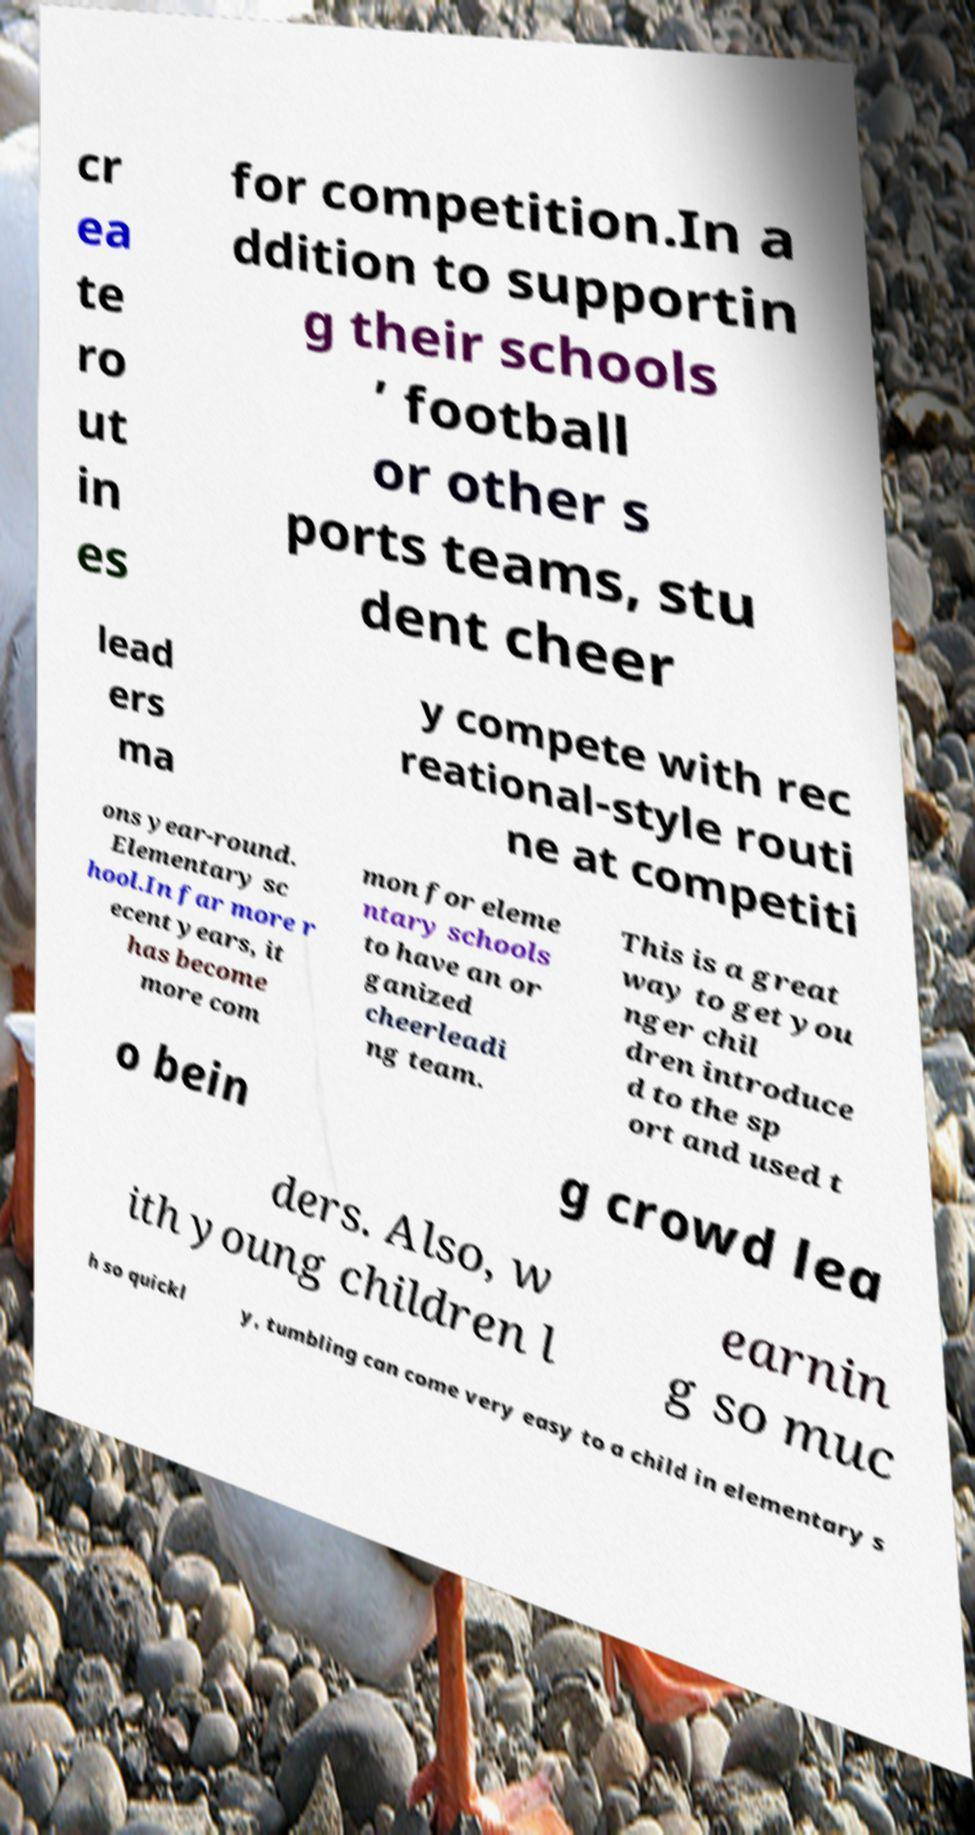Could you extract and type out the text from this image? cr ea te ro ut in es for competition.In a ddition to supportin g their schools ’ football or other s ports teams, stu dent cheer lead ers ma y compete with rec reational-style routi ne at competiti ons year-round. Elementary sc hool.In far more r ecent years, it has become more com mon for eleme ntary schools to have an or ganized cheerleadi ng team. This is a great way to get you nger chil dren introduce d to the sp ort and used t o bein g crowd lea ders. Also, w ith young children l earnin g so muc h so quickl y, tumbling can come very easy to a child in elementary s 